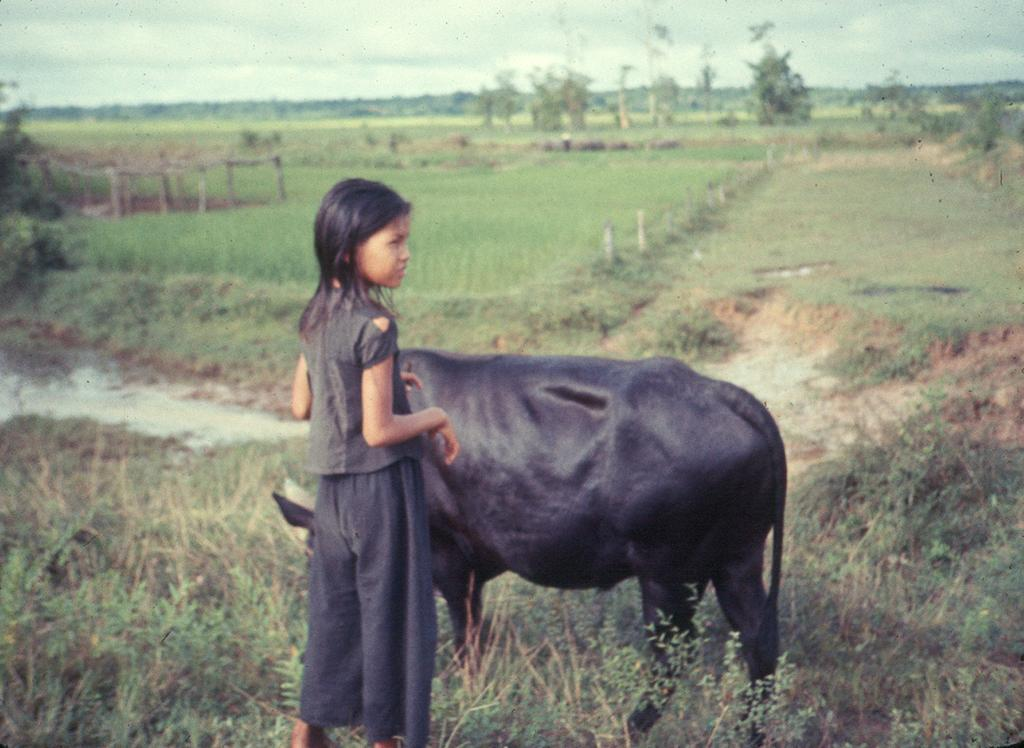What is the main subject of the image? There is a girl standing in the image. What animal is present in the image? There is a buffalo in the image. What type of vegetation is at the bottom of the image? Grass is present at the bottom of the image. What can be seen in the background of the image? There are trees and a field visible in the background. What is visible at the top of the image? The sky is visible at the top of the image. What type of tomatoes is the girl holding in the image? There are no tomatoes present in the image; the girl is not holding anything. Is the girl writing a letter while standing in the image? There is no indication that the girl is writing a letter or performing any writing-related activity in the image. 